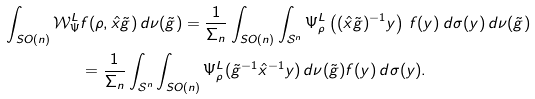<formula> <loc_0><loc_0><loc_500><loc_500>\int _ { S O ( n ) } \mathcal { W } _ { \Psi } ^ { L } & f ( \rho , \hat { x } \tilde { g } ) \, d \nu ( \tilde { g } ) = \frac { 1 } { \Sigma _ { n } } \int _ { S O ( n ) } \int _ { \mathcal { S } ^ { n } } \Psi _ { \rho } ^ { L } \left ( ( \hat { x } \tilde { g } ) ^ { - 1 } y \right ) \, f ( y ) \, d \sigma ( y ) \, d \nu ( \tilde { g } ) \\ & = \frac { 1 } { \Sigma _ { n } } \int _ { \mathcal { S } ^ { n } } \int _ { S O ( n ) } \Psi _ { \rho } ^ { L } ( \tilde { g } ^ { - 1 } \hat { x } ^ { - 1 } y ) \, d \nu ( \tilde { g } ) f ( y ) \, d \sigma ( y ) .</formula> 